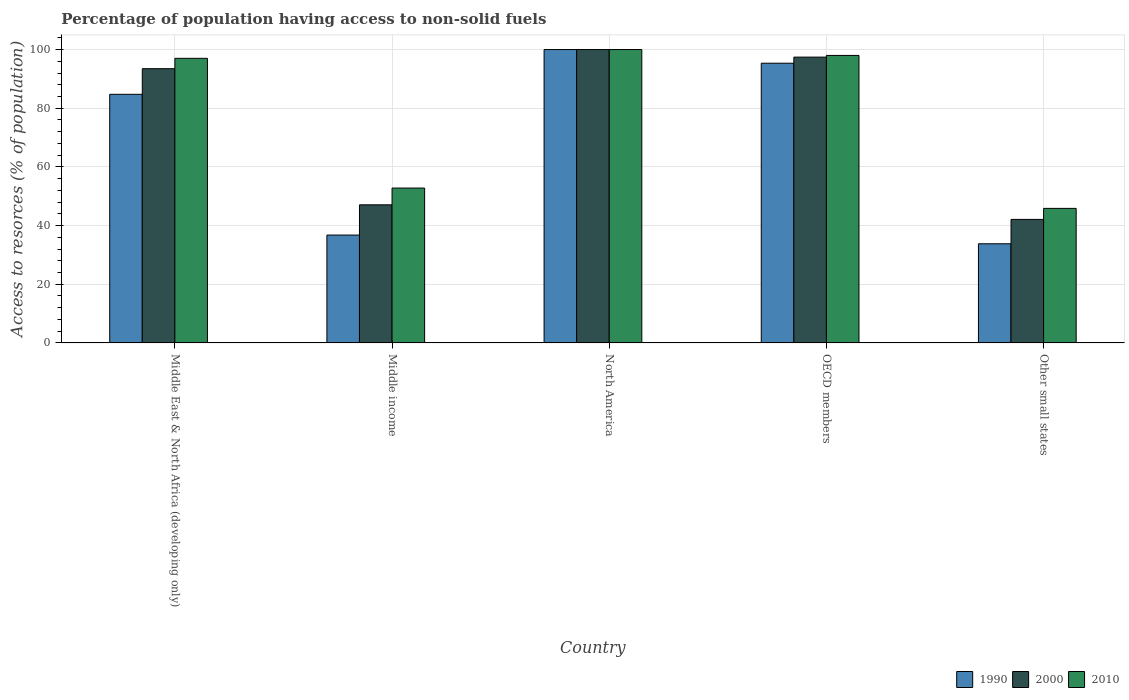How many different coloured bars are there?
Provide a succinct answer. 3. How many groups of bars are there?
Keep it short and to the point. 5. How many bars are there on the 3rd tick from the right?
Your response must be concise. 3. What is the label of the 1st group of bars from the left?
Provide a short and direct response. Middle East & North Africa (developing only). In how many cases, is the number of bars for a given country not equal to the number of legend labels?
Keep it short and to the point. 0. Across all countries, what is the maximum percentage of population having access to non-solid fuels in 1990?
Provide a short and direct response. 100. Across all countries, what is the minimum percentage of population having access to non-solid fuels in 2000?
Your answer should be compact. 42.11. In which country was the percentage of population having access to non-solid fuels in 2000 minimum?
Give a very brief answer. Other small states. What is the total percentage of population having access to non-solid fuels in 2010 in the graph?
Your response must be concise. 393.65. What is the difference between the percentage of population having access to non-solid fuels in 1990 in Middle income and that in OECD members?
Keep it short and to the point. -58.58. What is the difference between the percentage of population having access to non-solid fuels in 2000 in North America and the percentage of population having access to non-solid fuels in 1990 in Middle East & North Africa (developing only)?
Make the answer very short. 15.26. What is the average percentage of population having access to non-solid fuels in 1990 per country?
Keep it short and to the point. 70.13. What is the difference between the percentage of population having access to non-solid fuels of/in 1990 and percentage of population having access to non-solid fuels of/in 2000 in OECD members?
Provide a short and direct response. -2.07. What is the ratio of the percentage of population having access to non-solid fuels in 2010 in Middle East & North Africa (developing only) to that in Other small states?
Offer a very short reply. 2.12. Is the percentage of population having access to non-solid fuels in 2010 in Middle East & North Africa (developing only) less than that in OECD members?
Give a very brief answer. Yes. Is the difference between the percentage of population having access to non-solid fuels in 1990 in Middle East & North Africa (developing only) and OECD members greater than the difference between the percentage of population having access to non-solid fuels in 2000 in Middle East & North Africa (developing only) and OECD members?
Make the answer very short. No. What is the difference between the highest and the second highest percentage of population having access to non-solid fuels in 1990?
Ensure brevity in your answer.  -15.26. What is the difference between the highest and the lowest percentage of population having access to non-solid fuels in 2000?
Provide a short and direct response. 57.89. What does the 2nd bar from the right in Middle income represents?
Your answer should be very brief. 2000. Is it the case that in every country, the sum of the percentage of population having access to non-solid fuels in 2000 and percentage of population having access to non-solid fuels in 2010 is greater than the percentage of population having access to non-solid fuels in 1990?
Provide a short and direct response. Yes. Are all the bars in the graph horizontal?
Your answer should be very brief. No. How many countries are there in the graph?
Make the answer very short. 5. Does the graph contain any zero values?
Give a very brief answer. No. How are the legend labels stacked?
Offer a terse response. Horizontal. What is the title of the graph?
Your answer should be very brief. Percentage of population having access to non-solid fuels. Does "1964" appear as one of the legend labels in the graph?
Your response must be concise. No. What is the label or title of the Y-axis?
Make the answer very short. Access to resorces (% of population). What is the Access to resorces (% of population) of 1990 in Middle East & North Africa (developing only)?
Offer a very short reply. 84.74. What is the Access to resorces (% of population) in 2000 in Middle East & North Africa (developing only)?
Give a very brief answer. 93.48. What is the Access to resorces (% of population) of 2010 in Middle East & North Africa (developing only)?
Ensure brevity in your answer.  97.01. What is the Access to resorces (% of population) of 1990 in Middle income?
Offer a terse response. 36.77. What is the Access to resorces (% of population) in 2000 in Middle income?
Give a very brief answer. 47.08. What is the Access to resorces (% of population) of 2010 in Middle income?
Your answer should be compact. 52.79. What is the Access to resorces (% of population) of 1990 in OECD members?
Your answer should be compact. 95.34. What is the Access to resorces (% of population) of 2000 in OECD members?
Ensure brevity in your answer.  97.42. What is the Access to resorces (% of population) in 2010 in OECD members?
Provide a succinct answer. 97.99. What is the Access to resorces (% of population) in 1990 in Other small states?
Provide a succinct answer. 33.8. What is the Access to resorces (% of population) in 2000 in Other small states?
Provide a short and direct response. 42.11. What is the Access to resorces (% of population) of 2010 in Other small states?
Give a very brief answer. 45.86. Across all countries, what is the maximum Access to resorces (% of population) in 1990?
Offer a very short reply. 100. Across all countries, what is the minimum Access to resorces (% of population) in 1990?
Offer a terse response. 33.8. Across all countries, what is the minimum Access to resorces (% of population) in 2000?
Give a very brief answer. 42.11. Across all countries, what is the minimum Access to resorces (% of population) in 2010?
Provide a short and direct response. 45.86. What is the total Access to resorces (% of population) in 1990 in the graph?
Provide a succinct answer. 350.65. What is the total Access to resorces (% of population) in 2000 in the graph?
Your answer should be compact. 380.07. What is the total Access to resorces (% of population) of 2010 in the graph?
Your answer should be compact. 393.65. What is the difference between the Access to resorces (% of population) in 1990 in Middle East & North Africa (developing only) and that in Middle income?
Ensure brevity in your answer.  47.97. What is the difference between the Access to resorces (% of population) in 2000 in Middle East & North Africa (developing only) and that in Middle income?
Keep it short and to the point. 46.4. What is the difference between the Access to resorces (% of population) in 2010 in Middle East & North Africa (developing only) and that in Middle income?
Your response must be concise. 44.21. What is the difference between the Access to resorces (% of population) of 1990 in Middle East & North Africa (developing only) and that in North America?
Your answer should be very brief. -15.26. What is the difference between the Access to resorces (% of population) of 2000 in Middle East & North Africa (developing only) and that in North America?
Offer a very short reply. -6.52. What is the difference between the Access to resorces (% of population) in 2010 in Middle East & North Africa (developing only) and that in North America?
Your response must be concise. -2.99. What is the difference between the Access to resorces (% of population) in 1990 in Middle East & North Africa (developing only) and that in OECD members?
Your response must be concise. -10.6. What is the difference between the Access to resorces (% of population) in 2000 in Middle East & North Africa (developing only) and that in OECD members?
Offer a terse response. -3.94. What is the difference between the Access to resorces (% of population) of 2010 in Middle East & North Africa (developing only) and that in OECD members?
Offer a terse response. -0.98. What is the difference between the Access to resorces (% of population) of 1990 in Middle East & North Africa (developing only) and that in Other small states?
Offer a terse response. 50.94. What is the difference between the Access to resorces (% of population) of 2000 in Middle East & North Africa (developing only) and that in Other small states?
Offer a terse response. 51.37. What is the difference between the Access to resorces (% of population) in 2010 in Middle East & North Africa (developing only) and that in Other small states?
Ensure brevity in your answer.  51.15. What is the difference between the Access to resorces (% of population) in 1990 in Middle income and that in North America?
Provide a short and direct response. -63.23. What is the difference between the Access to resorces (% of population) of 2000 in Middle income and that in North America?
Give a very brief answer. -52.92. What is the difference between the Access to resorces (% of population) of 2010 in Middle income and that in North America?
Your answer should be very brief. -47.21. What is the difference between the Access to resorces (% of population) of 1990 in Middle income and that in OECD members?
Make the answer very short. -58.58. What is the difference between the Access to resorces (% of population) of 2000 in Middle income and that in OECD members?
Provide a short and direct response. -50.34. What is the difference between the Access to resorces (% of population) in 2010 in Middle income and that in OECD members?
Offer a very short reply. -45.2. What is the difference between the Access to resorces (% of population) in 1990 in Middle income and that in Other small states?
Make the answer very short. 2.97. What is the difference between the Access to resorces (% of population) of 2000 in Middle income and that in Other small states?
Your response must be concise. 4.97. What is the difference between the Access to resorces (% of population) of 2010 in Middle income and that in Other small states?
Make the answer very short. 6.93. What is the difference between the Access to resorces (% of population) of 1990 in North America and that in OECD members?
Ensure brevity in your answer.  4.66. What is the difference between the Access to resorces (% of population) in 2000 in North America and that in OECD members?
Your answer should be compact. 2.58. What is the difference between the Access to resorces (% of population) in 2010 in North America and that in OECD members?
Your answer should be very brief. 2.01. What is the difference between the Access to resorces (% of population) of 1990 in North America and that in Other small states?
Provide a succinct answer. 66.2. What is the difference between the Access to resorces (% of population) of 2000 in North America and that in Other small states?
Offer a terse response. 57.89. What is the difference between the Access to resorces (% of population) of 2010 in North America and that in Other small states?
Keep it short and to the point. 54.14. What is the difference between the Access to resorces (% of population) in 1990 in OECD members and that in Other small states?
Provide a succinct answer. 61.54. What is the difference between the Access to resorces (% of population) of 2000 in OECD members and that in Other small states?
Provide a succinct answer. 55.31. What is the difference between the Access to resorces (% of population) in 2010 in OECD members and that in Other small states?
Your answer should be compact. 52.13. What is the difference between the Access to resorces (% of population) in 1990 in Middle East & North Africa (developing only) and the Access to resorces (% of population) in 2000 in Middle income?
Offer a terse response. 37.67. What is the difference between the Access to resorces (% of population) of 1990 in Middle East & North Africa (developing only) and the Access to resorces (% of population) of 2010 in Middle income?
Provide a short and direct response. 31.95. What is the difference between the Access to resorces (% of population) in 2000 in Middle East & North Africa (developing only) and the Access to resorces (% of population) in 2010 in Middle income?
Provide a succinct answer. 40.68. What is the difference between the Access to resorces (% of population) of 1990 in Middle East & North Africa (developing only) and the Access to resorces (% of population) of 2000 in North America?
Offer a terse response. -15.26. What is the difference between the Access to resorces (% of population) in 1990 in Middle East & North Africa (developing only) and the Access to resorces (% of population) in 2010 in North America?
Ensure brevity in your answer.  -15.26. What is the difference between the Access to resorces (% of population) of 2000 in Middle East & North Africa (developing only) and the Access to resorces (% of population) of 2010 in North America?
Keep it short and to the point. -6.52. What is the difference between the Access to resorces (% of population) in 1990 in Middle East & North Africa (developing only) and the Access to resorces (% of population) in 2000 in OECD members?
Provide a short and direct response. -12.68. What is the difference between the Access to resorces (% of population) in 1990 in Middle East & North Africa (developing only) and the Access to resorces (% of population) in 2010 in OECD members?
Offer a very short reply. -13.25. What is the difference between the Access to resorces (% of population) in 2000 in Middle East & North Africa (developing only) and the Access to resorces (% of population) in 2010 in OECD members?
Your answer should be very brief. -4.52. What is the difference between the Access to resorces (% of population) of 1990 in Middle East & North Africa (developing only) and the Access to resorces (% of population) of 2000 in Other small states?
Your answer should be very brief. 42.64. What is the difference between the Access to resorces (% of population) of 1990 in Middle East & North Africa (developing only) and the Access to resorces (% of population) of 2010 in Other small states?
Your answer should be very brief. 38.88. What is the difference between the Access to resorces (% of population) of 2000 in Middle East & North Africa (developing only) and the Access to resorces (% of population) of 2010 in Other small states?
Ensure brevity in your answer.  47.62. What is the difference between the Access to resorces (% of population) in 1990 in Middle income and the Access to resorces (% of population) in 2000 in North America?
Your answer should be compact. -63.23. What is the difference between the Access to resorces (% of population) of 1990 in Middle income and the Access to resorces (% of population) of 2010 in North America?
Provide a succinct answer. -63.23. What is the difference between the Access to resorces (% of population) in 2000 in Middle income and the Access to resorces (% of population) in 2010 in North America?
Offer a terse response. -52.92. What is the difference between the Access to resorces (% of population) in 1990 in Middle income and the Access to resorces (% of population) in 2000 in OECD members?
Ensure brevity in your answer.  -60.65. What is the difference between the Access to resorces (% of population) of 1990 in Middle income and the Access to resorces (% of population) of 2010 in OECD members?
Keep it short and to the point. -61.22. What is the difference between the Access to resorces (% of population) of 2000 in Middle income and the Access to resorces (% of population) of 2010 in OECD members?
Your response must be concise. -50.92. What is the difference between the Access to resorces (% of population) of 1990 in Middle income and the Access to resorces (% of population) of 2000 in Other small states?
Make the answer very short. -5.34. What is the difference between the Access to resorces (% of population) of 1990 in Middle income and the Access to resorces (% of population) of 2010 in Other small states?
Ensure brevity in your answer.  -9.09. What is the difference between the Access to resorces (% of population) in 2000 in Middle income and the Access to resorces (% of population) in 2010 in Other small states?
Your answer should be compact. 1.22. What is the difference between the Access to resorces (% of population) of 1990 in North America and the Access to resorces (% of population) of 2000 in OECD members?
Make the answer very short. 2.58. What is the difference between the Access to resorces (% of population) of 1990 in North America and the Access to resorces (% of population) of 2010 in OECD members?
Provide a short and direct response. 2.01. What is the difference between the Access to resorces (% of population) of 2000 in North America and the Access to resorces (% of population) of 2010 in OECD members?
Keep it short and to the point. 2.01. What is the difference between the Access to resorces (% of population) of 1990 in North America and the Access to resorces (% of population) of 2000 in Other small states?
Offer a very short reply. 57.89. What is the difference between the Access to resorces (% of population) in 1990 in North America and the Access to resorces (% of population) in 2010 in Other small states?
Your response must be concise. 54.14. What is the difference between the Access to resorces (% of population) of 2000 in North America and the Access to resorces (% of population) of 2010 in Other small states?
Provide a succinct answer. 54.14. What is the difference between the Access to resorces (% of population) in 1990 in OECD members and the Access to resorces (% of population) in 2000 in Other small states?
Your response must be concise. 53.24. What is the difference between the Access to resorces (% of population) of 1990 in OECD members and the Access to resorces (% of population) of 2010 in Other small states?
Your response must be concise. 49.48. What is the difference between the Access to resorces (% of population) in 2000 in OECD members and the Access to resorces (% of population) in 2010 in Other small states?
Offer a very short reply. 51.56. What is the average Access to resorces (% of population) of 1990 per country?
Give a very brief answer. 70.13. What is the average Access to resorces (% of population) of 2000 per country?
Provide a short and direct response. 76.01. What is the average Access to resorces (% of population) in 2010 per country?
Keep it short and to the point. 78.73. What is the difference between the Access to resorces (% of population) in 1990 and Access to resorces (% of population) in 2000 in Middle East & North Africa (developing only)?
Give a very brief answer. -8.73. What is the difference between the Access to resorces (% of population) in 1990 and Access to resorces (% of population) in 2010 in Middle East & North Africa (developing only)?
Make the answer very short. -12.27. What is the difference between the Access to resorces (% of population) in 2000 and Access to resorces (% of population) in 2010 in Middle East & North Africa (developing only)?
Offer a very short reply. -3.53. What is the difference between the Access to resorces (% of population) of 1990 and Access to resorces (% of population) of 2000 in Middle income?
Provide a short and direct response. -10.31. What is the difference between the Access to resorces (% of population) of 1990 and Access to resorces (% of population) of 2010 in Middle income?
Give a very brief answer. -16.03. What is the difference between the Access to resorces (% of population) in 2000 and Access to resorces (% of population) in 2010 in Middle income?
Offer a very short reply. -5.72. What is the difference between the Access to resorces (% of population) in 2000 and Access to resorces (% of population) in 2010 in North America?
Offer a terse response. 0. What is the difference between the Access to resorces (% of population) in 1990 and Access to resorces (% of population) in 2000 in OECD members?
Your response must be concise. -2.07. What is the difference between the Access to resorces (% of population) in 1990 and Access to resorces (% of population) in 2010 in OECD members?
Ensure brevity in your answer.  -2.65. What is the difference between the Access to resorces (% of population) in 2000 and Access to resorces (% of population) in 2010 in OECD members?
Give a very brief answer. -0.57. What is the difference between the Access to resorces (% of population) in 1990 and Access to resorces (% of population) in 2000 in Other small states?
Your response must be concise. -8.31. What is the difference between the Access to resorces (% of population) of 1990 and Access to resorces (% of population) of 2010 in Other small states?
Offer a very short reply. -12.06. What is the difference between the Access to resorces (% of population) in 2000 and Access to resorces (% of population) in 2010 in Other small states?
Provide a short and direct response. -3.75. What is the ratio of the Access to resorces (% of population) of 1990 in Middle East & North Africa (developing only) to that in Middle income?
Provide a short and direct response. 2.3. What is the ratio of the Access to resorces (% of population) of 2000 in Middle East & North Africa (developing only) to that in Middle income?
Offer a very short reply. 1.99. What is the ratio of the Access to resorces (% of population) in 2010 in Middle East & North Africa (developing only) to that in Middle income?
Your answer should be compact. 1.84. What is the ratio of the Access to resorces (% of population) in 1990 in Middle East & North Africa (developing only) to that in North America?
Keep it short and to the point. 0.85. What is the ratio of the Access to resorces (% of population) in 2000 in Middle East & North Africa (developing only) to that in North America?
Ensure brevity in your answer.  0.93. What is the ratio of the Access to resorces (% of population) of 2010 in Middle East & North Africa (developing only) to that in North America?
Offer a terse response. 0.97. What is the ratio of the Access to resorces (% of population) in 1990 in Middle East & North Africa (developing only) to that in OECD members?
Give a very brief answer. 0.89. What is the ratio of the Access to resorces (% of population) in 2000 in Middle East & North Africa (developing only) to that in OECD members?
Provide a short and direct response. 0.96. What is the ratio of the Access to resorces (% of population) in 1990 in Middle East & North Africa (developing only) to that in Other small states?
Your answer should be compact. 2.51. What is the ratio of the Access to resorces (% of population) in 2000 in Middle East & North Africa (developing only) to that in Other small states?
Your answer should be compact. 2.22. What is the ratio of the Access to resorces (% of population) of 2010 in Middle East & North Africa (developing only) to that in Other small states?
Make the answer very short. 2.12. What is the ratio of the Access to resorces (% of population) in 1990 in Middle income to that in North America?
Provide a succinct answer. 0.37. What is the ratio of the Access to resorces (% of population) in 2000 in Middle income to that in North America?
Offer a very short reply. 0.47. What is the ratio of the Access to resorces (% of population) in 2010 in Middle income to that in North America?
Keep it short and to the point. 0.53. What is the ratio of the Access to resorces (% of population) of 1990 in Middle income to that in OECD members?
Provide a succinct answer. 0.39. What is the ratio of the Access to resorces (% of population) of 2000 in Middle income to that in OECD members?
Your response must be concise. 0.48. What is the ratio of the Access to resorces (% of population) of 2010 in Middle income to that in OECD members?
Keep it short and to the point. 0.54. What is the ratio of the Access to resorces (% of population) of 1990 in Middle income to that in Other small states?
Give a very brief answer. 1.09. What is the ratio of the Access to resorces (% of population) in 2000 in Middle income to that in Other small states?
Give a very brief answer. 1.12. What is the ratio of the Access to resorces (% of population) in 2010 in Middle income to that in Other small states?
Provide a succinct answer. 1.15. What is the ratio of the Access to resorces (% of population) in 1990 in North America to that in OECD members?
Offer a terse response. 1.05. What is the ratio of the Access to resorces (% of population) in 2000 in North America to that in OECD members?
Provide a short and direct response. 1.03. What is the ratio of the Access to resorces (% of population) of 2010 in North America to that in OECD members?
Your answer should be very brief. 1.02. What is the ratio of the Access to resorces (% of population) of 1990 in North America to that in Other small states?
Offer a very short reply. 2.96. What is the ratio of the Access to resorces (% of population) in 2000 in North America to that in Other small states?
Provide a short and direct response. 2.38. What is the ratio of the Access to resorces (% of population) of 2010 in North America to that in Other small states?
Offer a very short reply. 2.18. What is the ratio of the Access to resorces (% of population) in 1990 in OECD members to that in Other small states?
Your answer should be very brief. 2.82. What is the ratio of the Access to resorces (% of population) in 2000 in OECD members to that in Other small states?
Ensure brevity in your answer.  2.31. What is the ratio of the Access to resorces (% of population) of 2010 in OECD members to that in Other small states?
Make the answer very short. 2.14. What is the difference between the highest and the second highest Access to resorces (% of population) of 1990?
Make the answer very short. 4.66. What is the difference between the highest and the second highest Access to resorces (% of population) in 2000?
Your answer should be very brief. 2.58. What is the difference between the highest and the second highest Access to resorces (% of population) of 2010?
Your response must be concise. 2.01. What is the difference between the highest and the lowest Access to resorces (% of population) of 1990?
Provide a succinct answer. 66.2. What is the difference between the highest and the lowest Access to resorces (% of population) in 2000?
Ensure brevity in your answer.  57.89. What is the difference between the highest and the lowest Access to resorces (% of population) in 2010?
Ensure brevity in your answer.  54.14. 